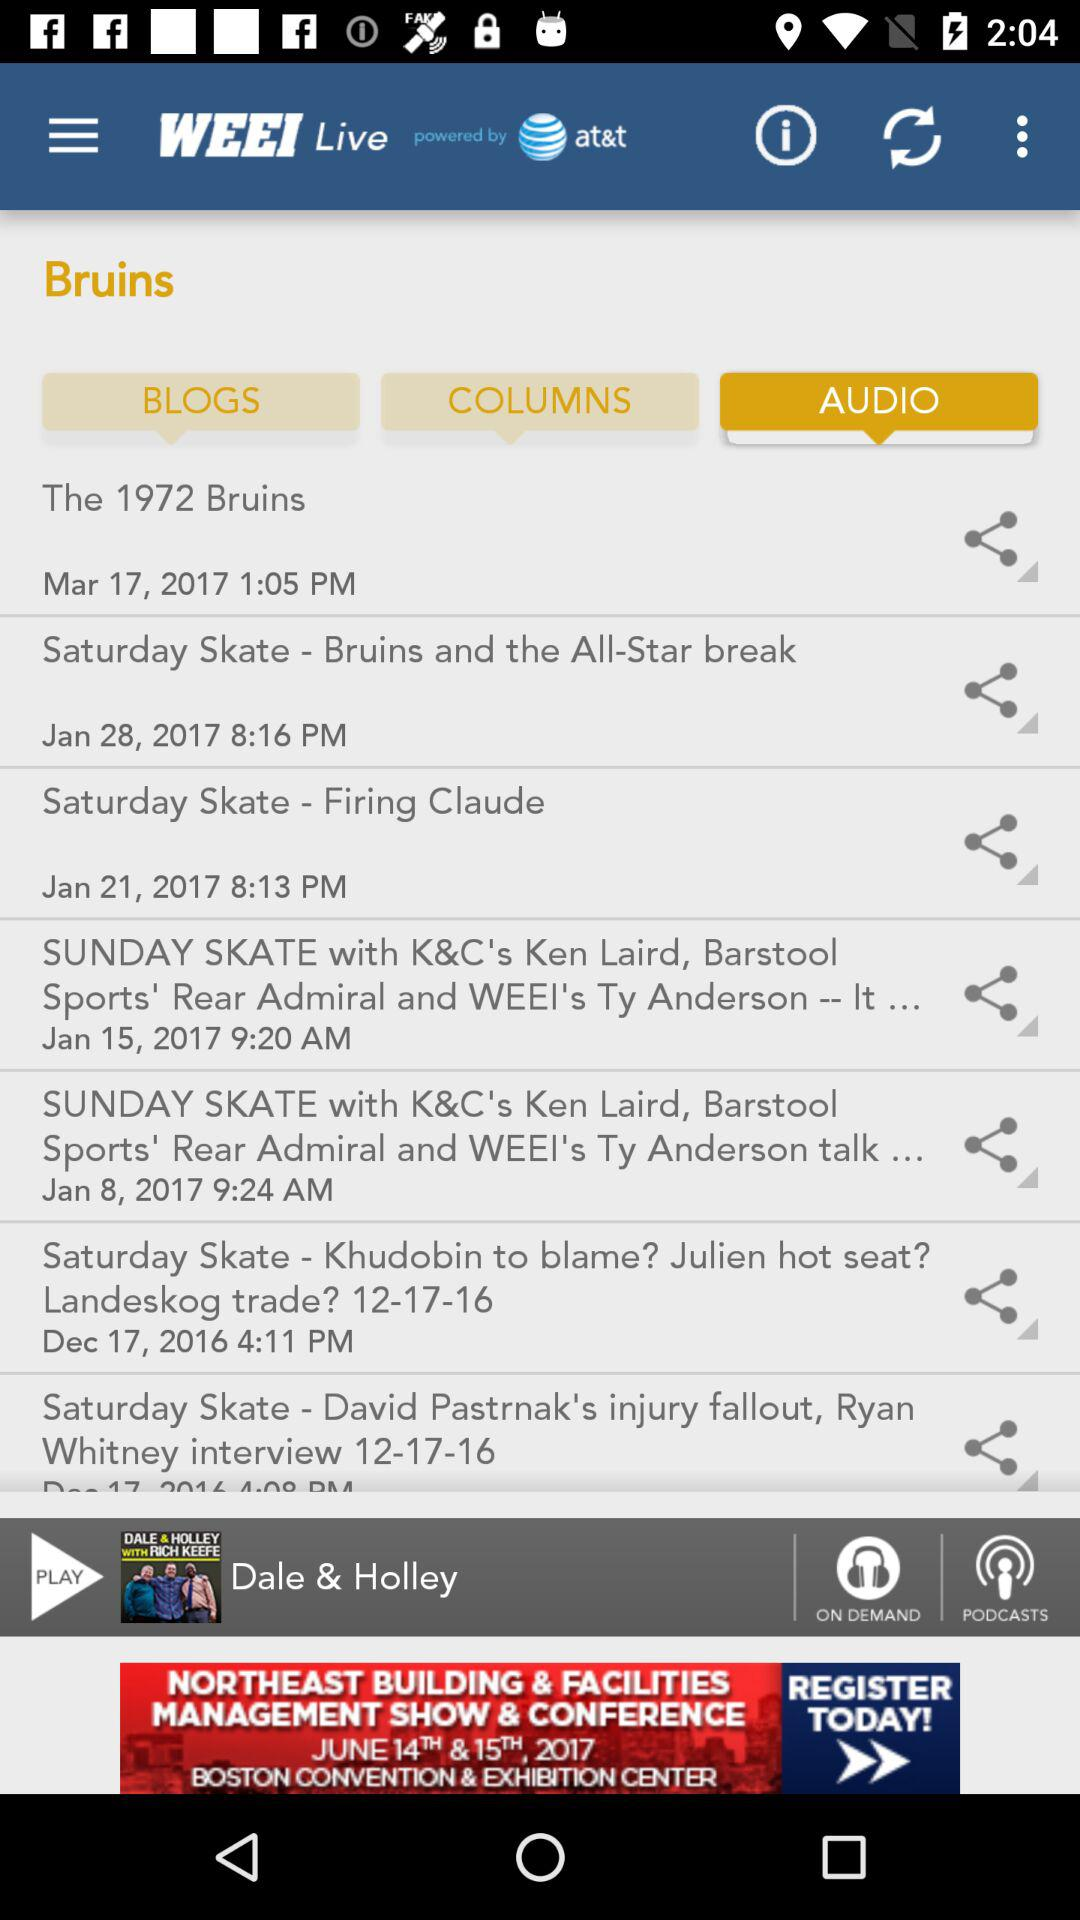What is the selected tab? The selected tab is "AUDIO". 